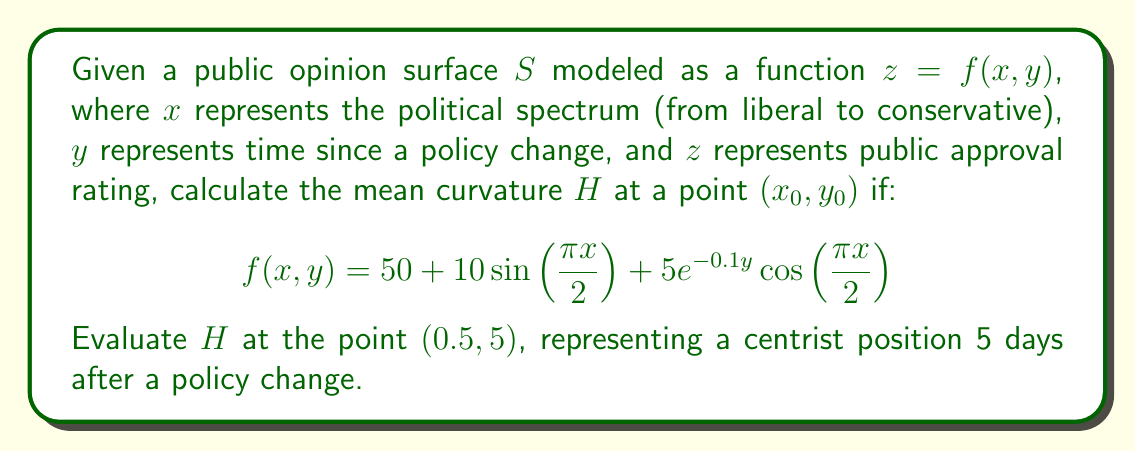Provide a solution to this math problem. To calculate the mean curvature $H$ of the surface $z = f(x, y)$ at a point $(x_0, y_0)$, we use the formula:

$$H = \frac{(1 + f_y^2)f_{xx} - 2f_xf_yf_{xy} + (1 + f_x^2)f_{yy}}{2(1 + f_x^2 + f_y^2)^{3/2}}$$

Where $f_x, f_y$ are first partial derivatives, and $f_{xx}, f_{xy}, f_{yy}$ are second partial derivatives.

Step 1: Calculate first partial derivatives:
$$f_x = 5\pi\cos(\frac{\pi x}{2}) - \frac{5\pi}{2}e^{-0.1y}\sin(\frac{\pi x}{2})$$
$$f_y = -0.5e^{-0.1y}\cos(\frac{\pi x}{2})$$

Step 2: Calculate second partial derivatives:
$$f_{xx} = -\frac{25\pi^2}{4}\sin(\frac{\pi x}{2}) - \frac{5\pi^2}{4}e^{-0.1y}\cos(\frac{\pi x}{2})$$
$$f_{xy} = \frac{\pi}{4}e^{-0.1y}\sin(\frac{\pi x}{2})$$
$$f_{yy} = 0.05e^{-0.1y}\cos(\frac{\pi x}{2})$$

Step 3: Evaluate derivatives at $(x_0, y_0) = (0.5, 5)$:
$$f_x(0.5, 5) = 5\pi\cos(\frac{\pi}{4}) - \frac{5\pi}{2}e^{-0.5}\sin(\frac{\pi}{4}) \approx 7.3185$$
$$f_y(0.5, 5) = -0.5e^{-0.5}\cos(\frac{\pi}{4}) \approx -0.2165$$
$$f_{xx}(0.5, 5) = -\frac{25\pi^2}{4}\sin(\frac{\pi}{4}) - \frac{5\pi^2}{4}e^{-0.5}\cos(\frac{\pi}{4}) \approx -38.0677$$
$$f_{xy}(0.5, 5) = \frac{\pi}{4}e^{-0.5}\sin(\frac{\pi}{4}) \approx 0.3398$$
$$f_{yy}(0.5, 5) = 0.05e^{-0.5}\cos(\frac{\pi}{4}) \approx 0.0216$$

Step 4: Substitute values into the mean curvature formula:
$$H = \frac{(1 + (-0.2165)^2)(-38.0677) - 2(7.3185)(-0.2165)(0.3398) + (1 + 7.3185^2)(0.0216)}{2(1 + 7.3185^2 + (-0.2165)^2)^{3/2}}$$

Step 5: Simplify and calculate the final result:
$$H \approx -0.6804$$
Answer: $H \approx -0.6804$ 